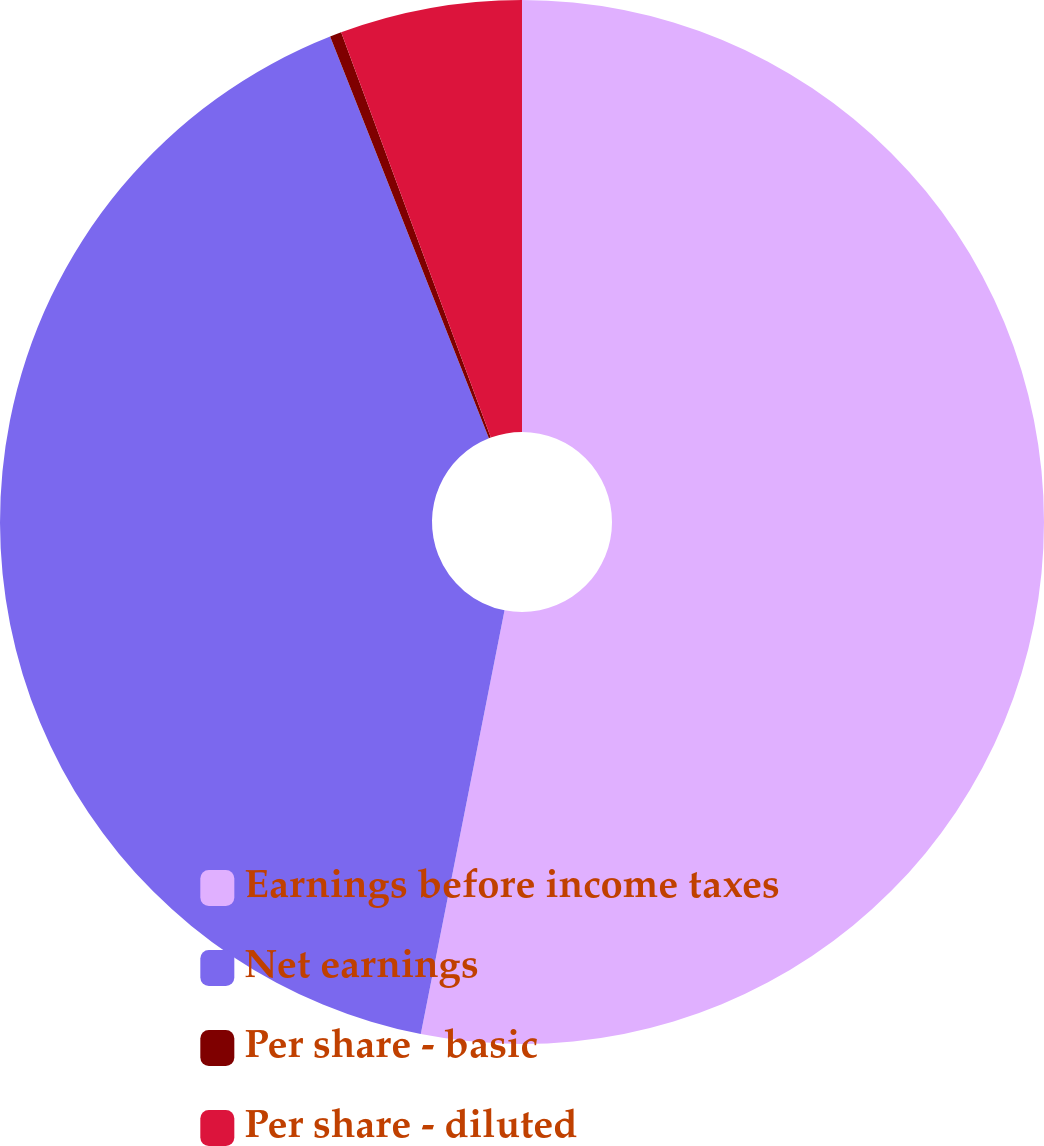Convert chart. <chart><loc_0><loc_0><loc_500><loc_500><pie_chart><fcel>Earnings before income taxes<fcel>Net earnings<fcel>Per share - basic<fcel>Per share - diluted<nl><fcel>53.1%<fcel>40.9%<fcel>0.36%<fcel>5.63%<nl></chart> 